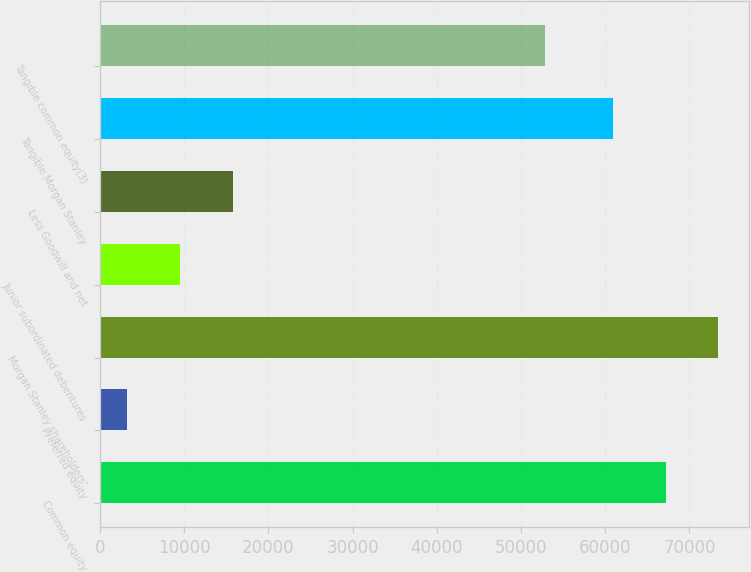Convert chart. <chart><loc_0><loc_0><loc_500><loc_500><bar_chart><fcel>Common equity<fcel>Preferred equity<fcel>Morgan Stanley shareholders'<fcel>Junior subordinated debentures<fcel>Less Goodwill and net<fcel>Tangible Morgan Stanley<fcel>Tangible common equity(3)<nl><fcel>67167.1<fcel>3220<fcel>73437.2<fcel>9490.1<fcel>15760.2<fcel>60897<fcel>52828<nl></chart> 